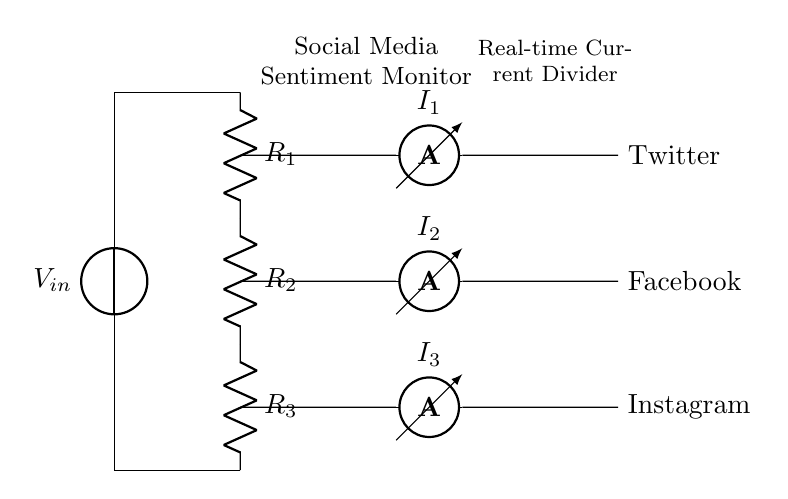What is the input voltage of this circuit? The input voltage, labeled as V_in, is displayed at the top of the circuit diagram. It represents the source voltage that initiates the current flow in the divider.
Answer: V_in What are the resistances in this circuit? The circuit contains three resistors labeled R_1, R_2, and R_3. Each resistor's value is indicated next to it in the diagram.
Answer: R_1, R_2, R_3 How many ammeters are present in the circuit? The circuit displays three ammeters connected in parallel, each measuring the current through specific branches. They are labeled I_1, I_2, and I_3.
Answer: Three What do the ammeters measure in relation to social media? Each ammeter corresponds to a different social media platform: I_1 measures current related to Twitter, I_2 for Facebook, and I_3 for Instagram. This indicates that the circuit monitors sentiment from these platforms.
Answer: Twitter, Facebook, Instagram If R_1, R_2, and R_3 were equal, how would the current divide among the ammeters? When resistors are equal, the total current divides equally among them. Therefore, each ammeter would measure the same current value if the resistors have identical resistance values.
Answer: Equal division What is the main function of this circuit? The primary function of the circuit is to act as a social media sentiment monitor in real-time, dividing the current to measure the response from different platforms simultaneously.
Answer: Social media sentiment monitor 